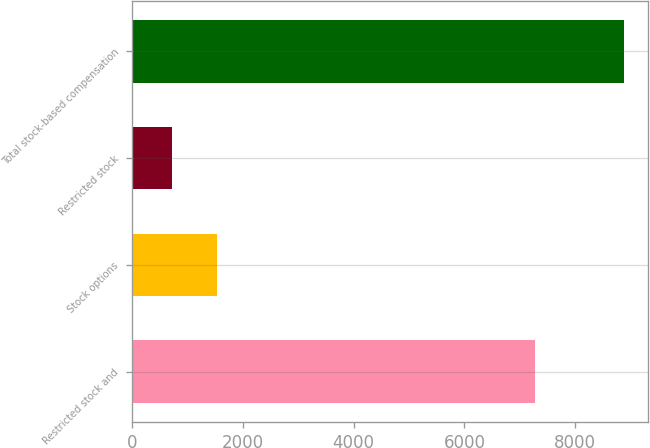<chart> <loc_0><loc_0><loc_500><loc_500><bar_chart><fcel>Restricted stock and<fcel>Stock options<fcel>Restricted stock<fcel>Total stock-based compensation<nl><fcel>7269<fcel>1526.9<fcel>710<fcel>8879<nl></chart> 